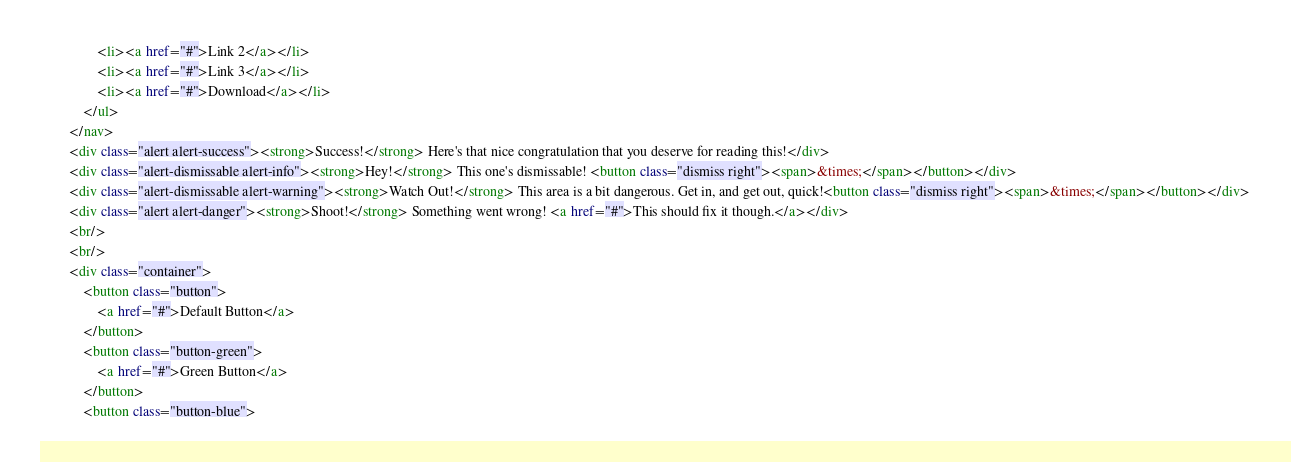<code> <loc_0><loc_0><loc_500><loc_500><_HTML_>                <li><a href="#">Link 2</a></li>
                <li><a href="#">Link 3</a></li>
                <li><a href="#">Download</a></li>
            </ul>
        </nav>
        <div class="alert alert-success"><strong>Success!</strong> Here's that nice congratulation that you deserve for reading this!</div>
        <div class="alert-dismissable alert-info"><strong>Hey!</strong> This one's dismissable! <button class="dismiss right"><span>&times;</span></button></div>
        <div class="alert-dismissable alert-warning"><strong>Watch Out!</strong> This area is a bit dangerous. Get in, and get out, quick!<button class="dismiss right"><span>&times;</span></button></div>
        <div class="alert alert-danger"><strong>Shoot!</strong> Something went wrong! <a href="#">This should fix it though.</a></div>
        <br/>
        <br/>
        <div class="container">
            <button class="button">
                <a href="#">Default Button</a>
            </button>
            <button class="button-green">
                <a href="#">Green Button</a>
            </button>
            <button class="button-blue"></code> 